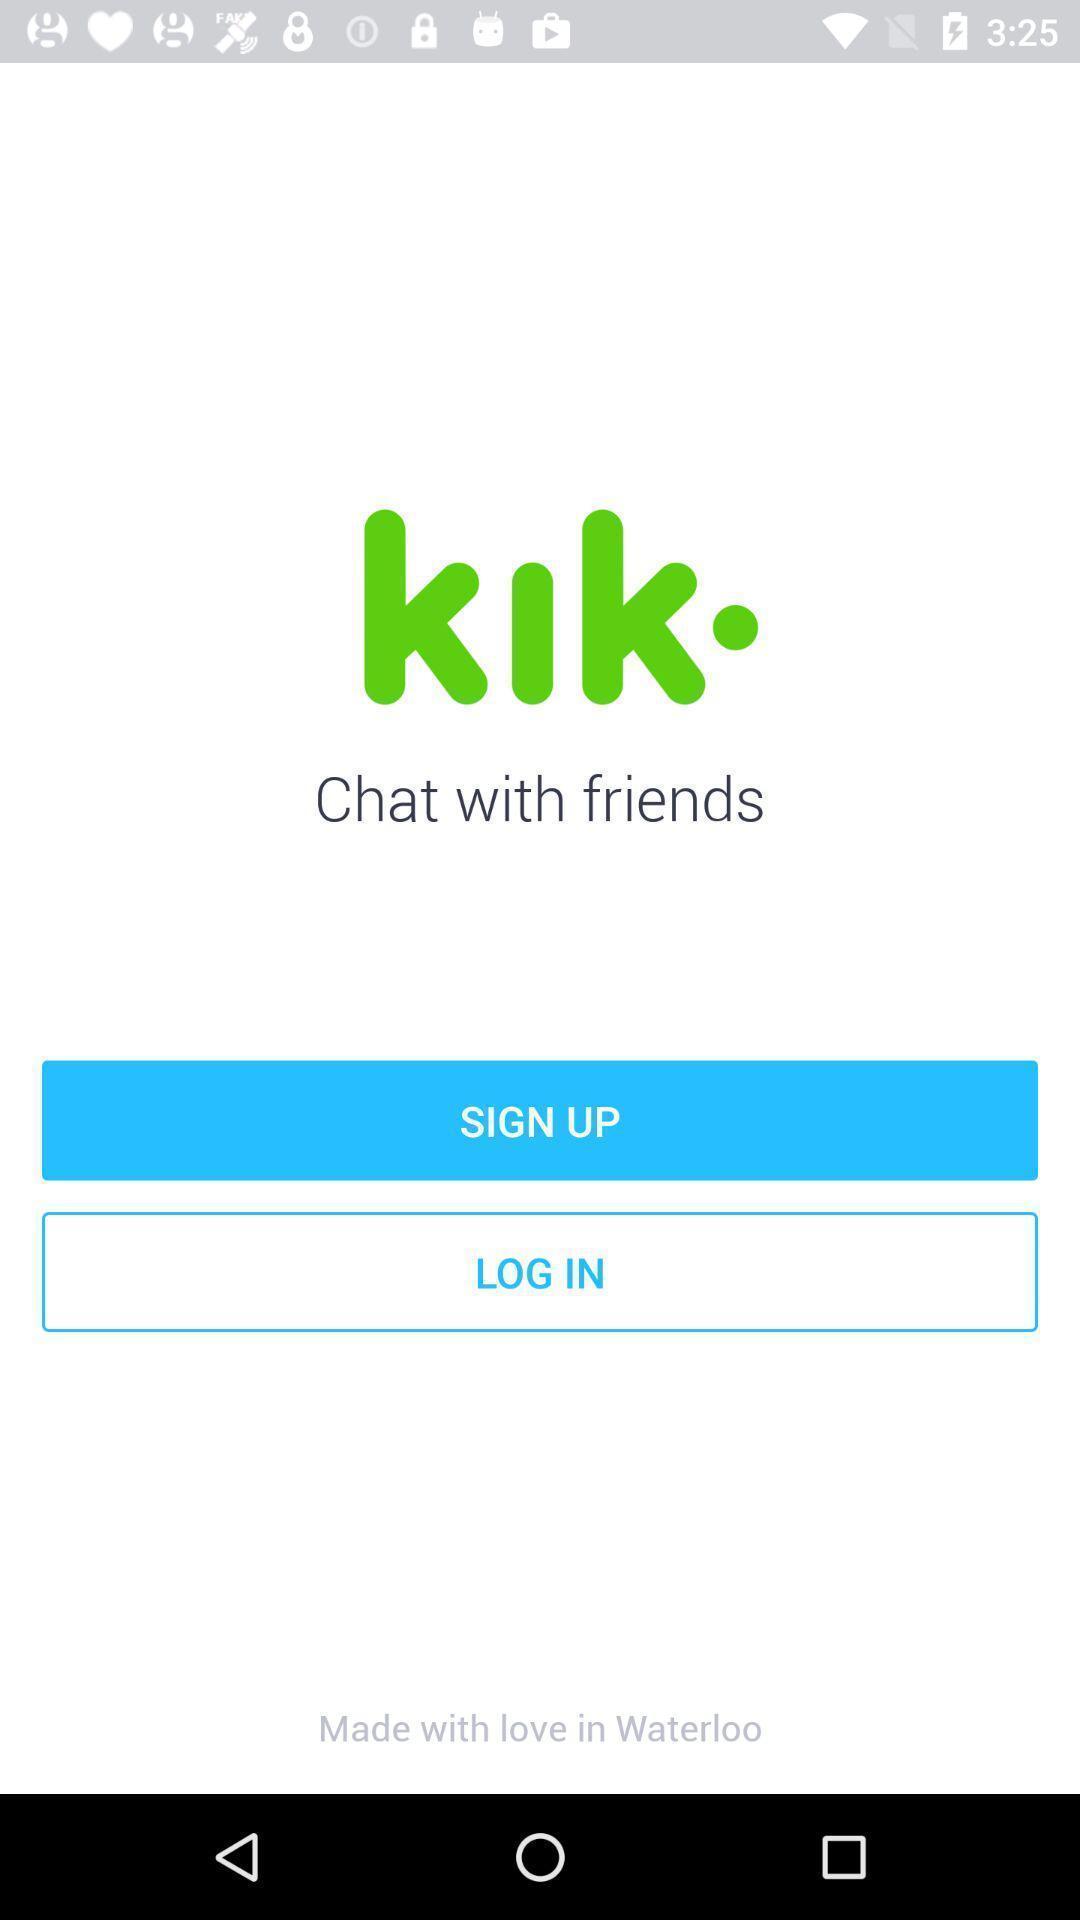Describe the content in this image. Sign up/log in page of messaging application. 